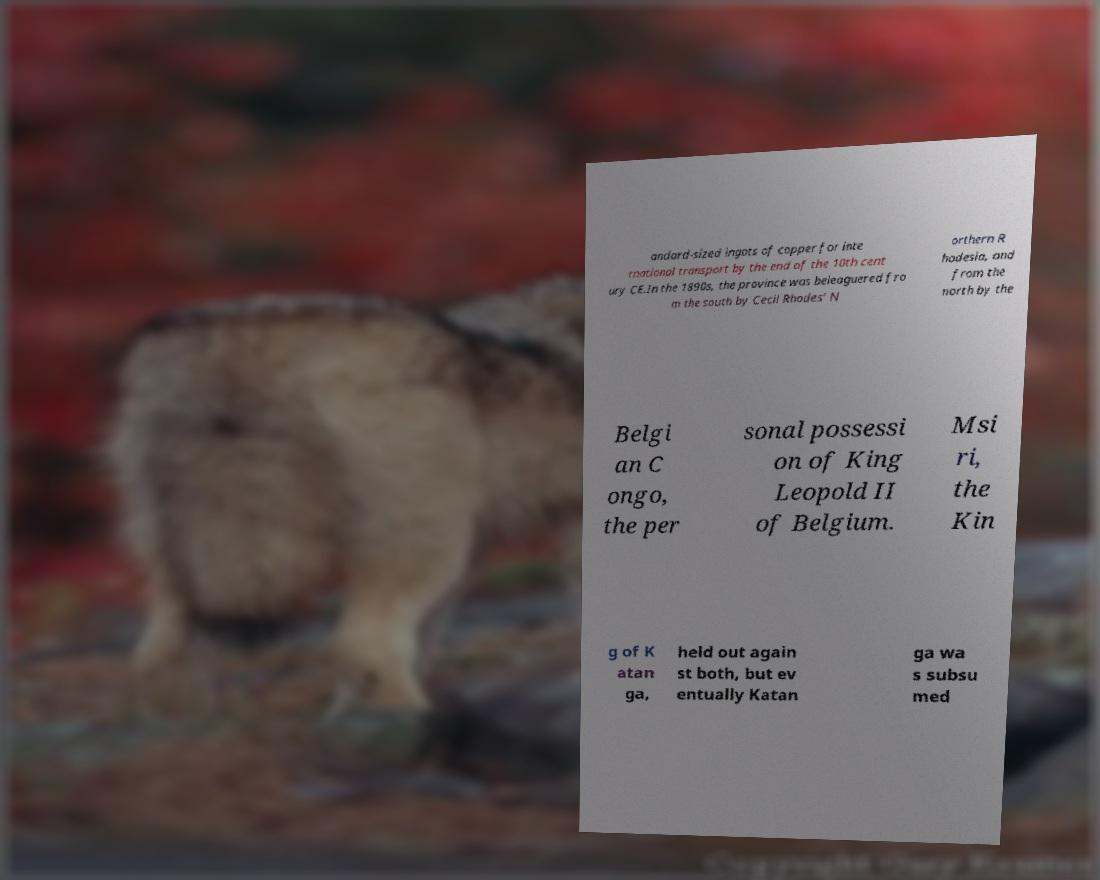Please read and relay the text visible in this image. What does it say? andard-sized ingots of copper for inte rnational transport by the end of the 10th cent ury CE.In the 1890s, the province was beleaguered fro m the south by Cecil Rhodes' N orthern R hodesia, and from the north by the Belgi an C ongo, the per sonal possessi on of King Leopold II of Belgium. Msi ri, the Kin g of K atan ga, held out again st both, but ev entually Katan ga wa s subsu med 